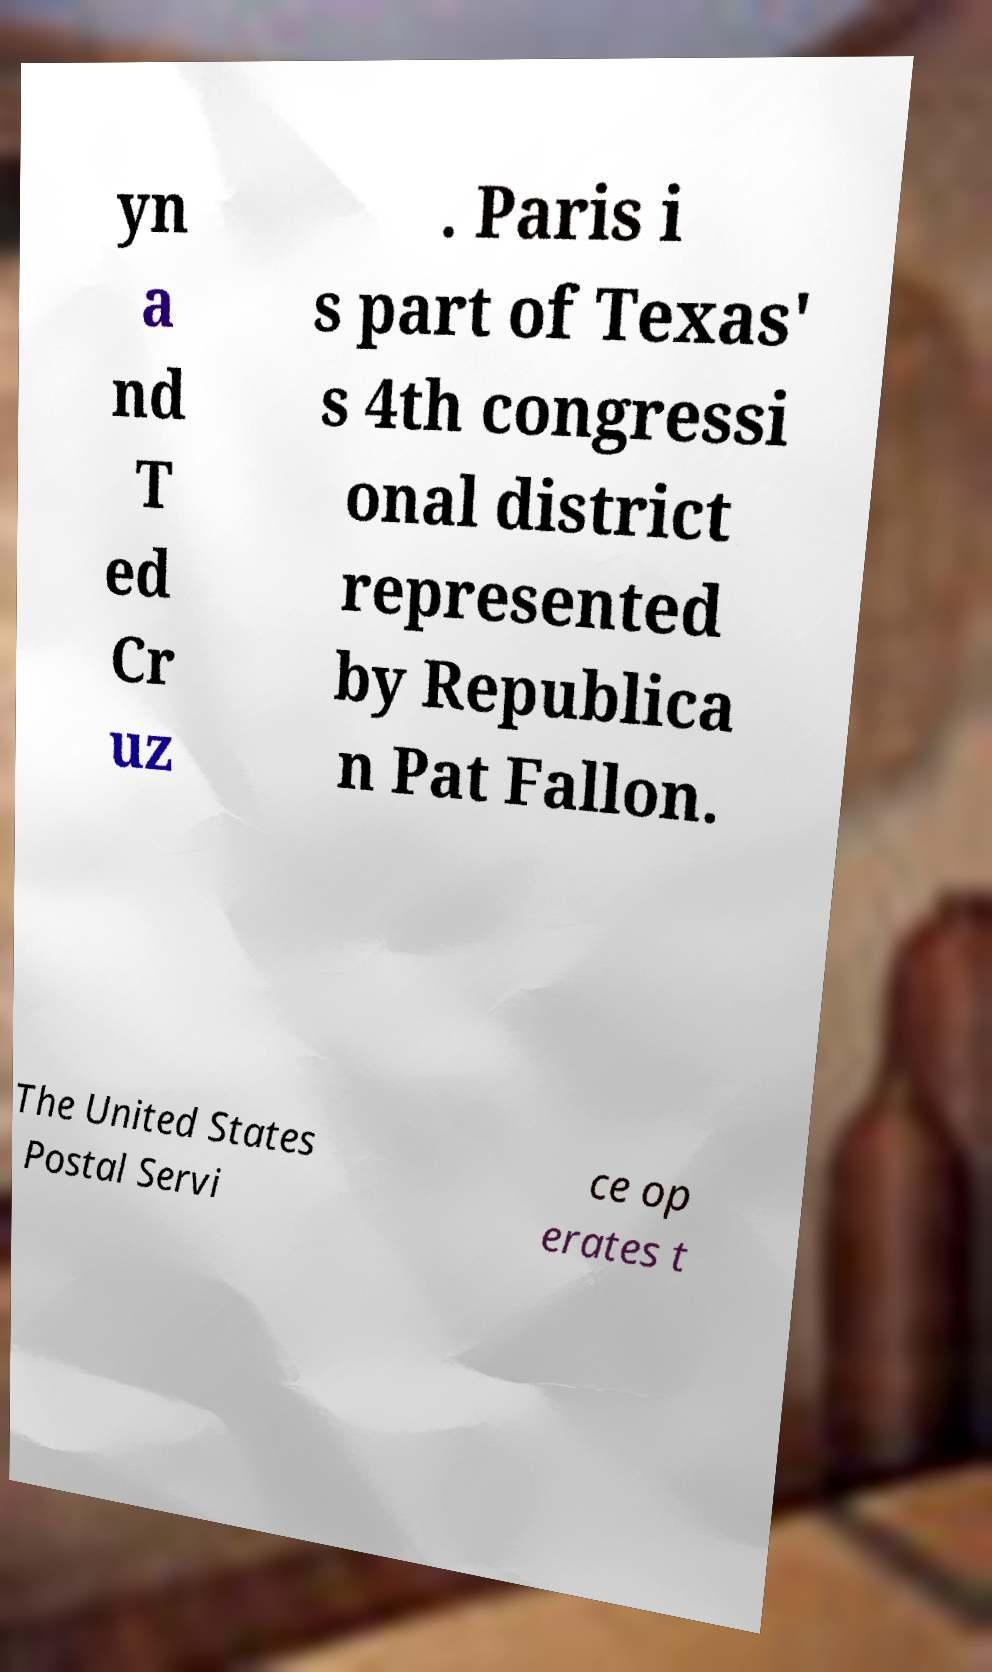Could you extract and type out the text from this image? yn a nd T ed Cr uz . Paris i s part of Texas' s 4th congressi onal district represented by Republica n Pat Fallon. The United States Postal Servi ce op erates t 